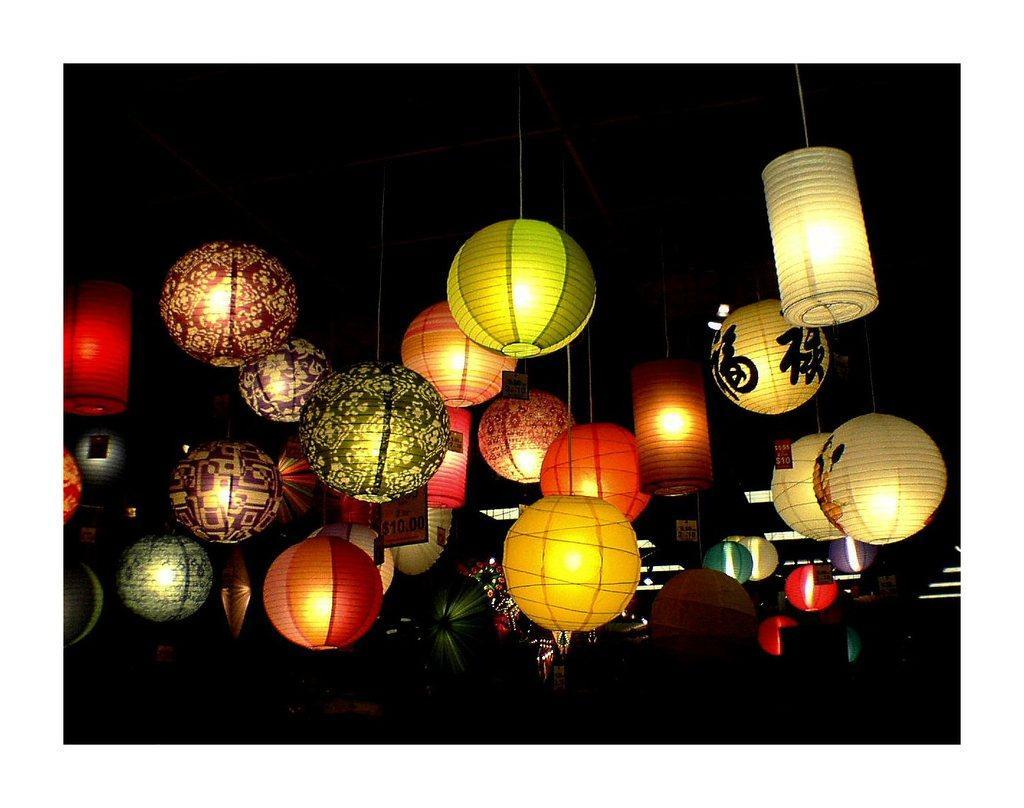Describe this image in one or two sentences. In this image we can see there are lights attached to the ceiling. 